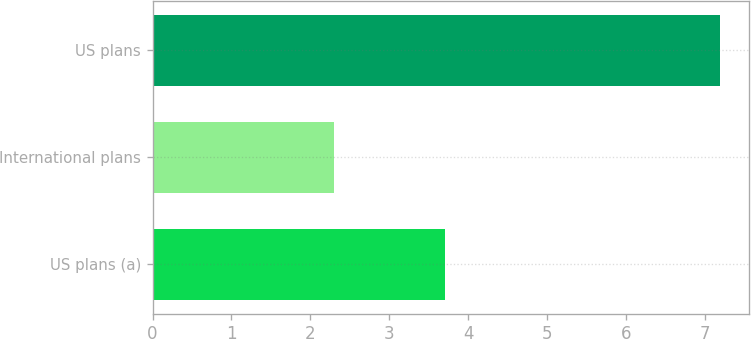<chart> <loc_0><loc_0><loc_500><loc_500><bar_chart><fcel>US plans (a)<fcel>International plans<fcel>US plans<nl><fcel>3.71<fcel>2.3<fcel>7.2<nl></chart> 